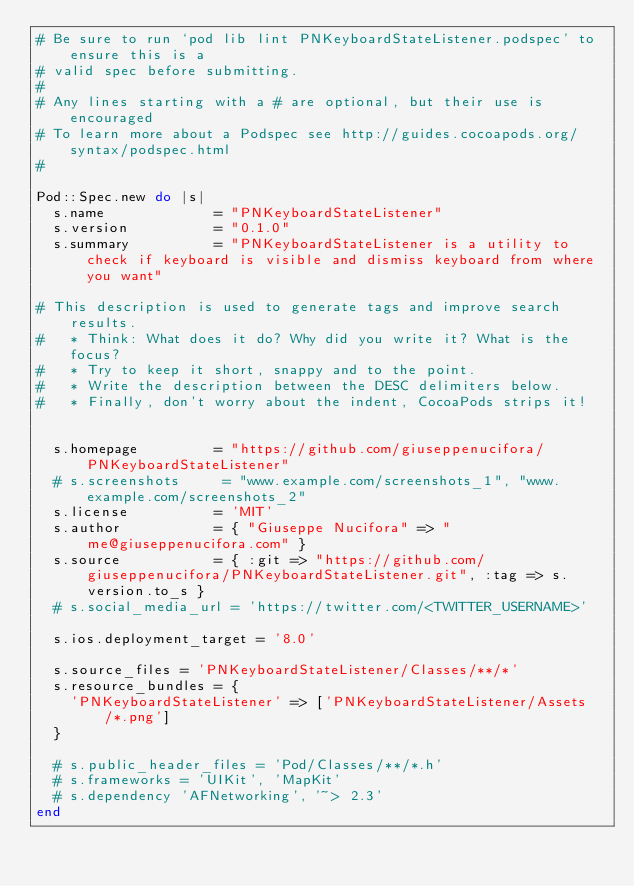<code> <loc_0><loc_0><loc_500><loc_500><_Ruby_># Be sure to run `pod lib lint PNKeyboardStateListener.podspec' to ensure this is a
# valid spec before submitting.
#
# Any lines starting with a # are optional, but their use is encouraged
# To learn more about a Podspec see http://guides.cocoapods.org/syntax/podspec.html
#

Pod::Spec.new do |s|
  s.name             = "PNKeyboardStateListener"
  s.version          = "0.1.0"
  s.summary          = "PNKeyboardStateListener is a utility to check if keyboard is visible and dismiss keyboard from where you want"

# This description is used to generate tags and improve search results.
#   * Think: What does it do? Why did you write it? What is the focus?
#   * Try to keep it short, snappy and to the point.
#   * Write the description between the DESC delimiters below.
#   * Finally, don't worry about the indent, CocoaPods strips it!


  s.homepage         = "https://github.com/giuseppenucifora/PNKeyboardStateListener"
  # s.screenshots     = "www.example.com/screenshots_1", "www.example.com/screenshots_2"
  s.license          = 'MIT'
  s.author           = { "Giuseppe Nucifora" => "me@giuseppenucifora.com" }
  s.source           = { :git => "https://github.com/giuseppenucifora/PNKeyboardStateListener.git", :tag => s.version.to_s }
  # s.social_media_url = 'https://twitter.com/<TWITTER_USERNAME>'

  s.ios.deployment_target = '8.0'

  s.source_files = 'PNKeyboardStateListener/Classes/**/*'
  s.resource_bundles = {
    'PNKeyboardStateListener' => ['PNKeyboardStateListener/Assets/*.png']
  }

  # s.public_header_files = 'Pod/Classes/**/*.h'
  # s.frameworks = 'UIKit', 'MapKit'
  # s.dependency 'AFNetworking', '~> 2.3'
end
</code> 